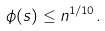Convert formula to latex. <formula><loc_0><loc_0><loc_500><loc_500>\phi ( s ) \leq n ^ { 1 / 1 0 } .</formula> 